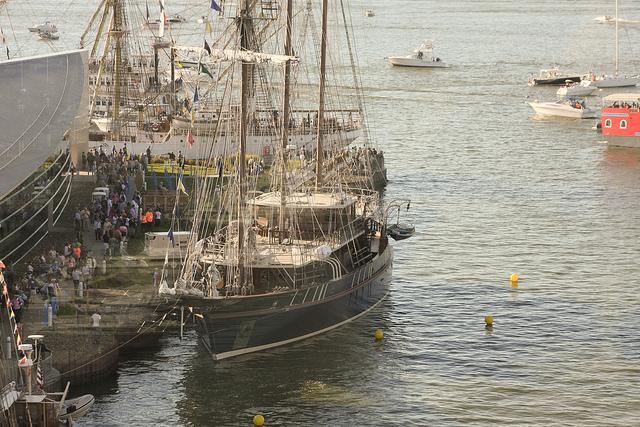How many boats are in the water?
Concise answer only. 15. Is the ship a high tech ship?
Short answer required. No. Is the water still?
Write a very short answer. Yes. How many boats are there?
Be succinct. 5. Is this a military ship?
Answer briefly. No. 